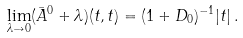<formula> <loc_0><loc_0><loc_500><loc_500>\lim _ { \lambda \to 0 } ( \bar { A } ^ { 0 } + \lambda ) ( t , t ) = ( 1 + D _ { 0 } ) ^ { - 1 } | t | \, .</formula> 